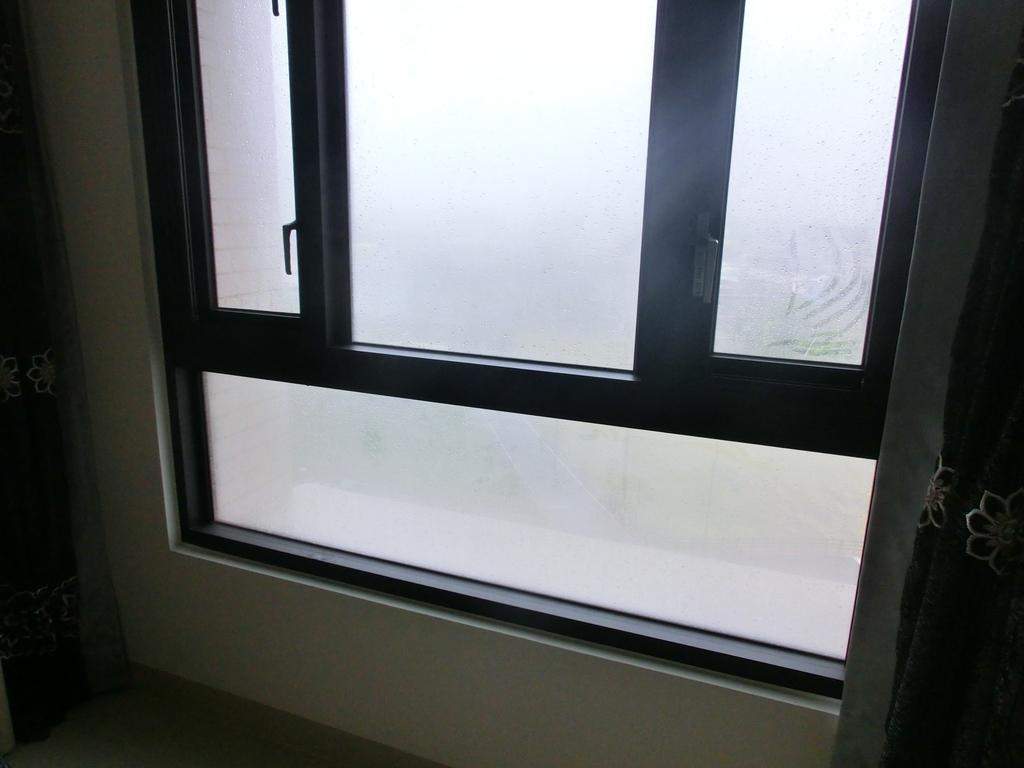How would you summarize this image in a sentence or two? In this image in the center there is one window and on the right side and left side there are some curtains and wall, at the bottom there is a floor. 